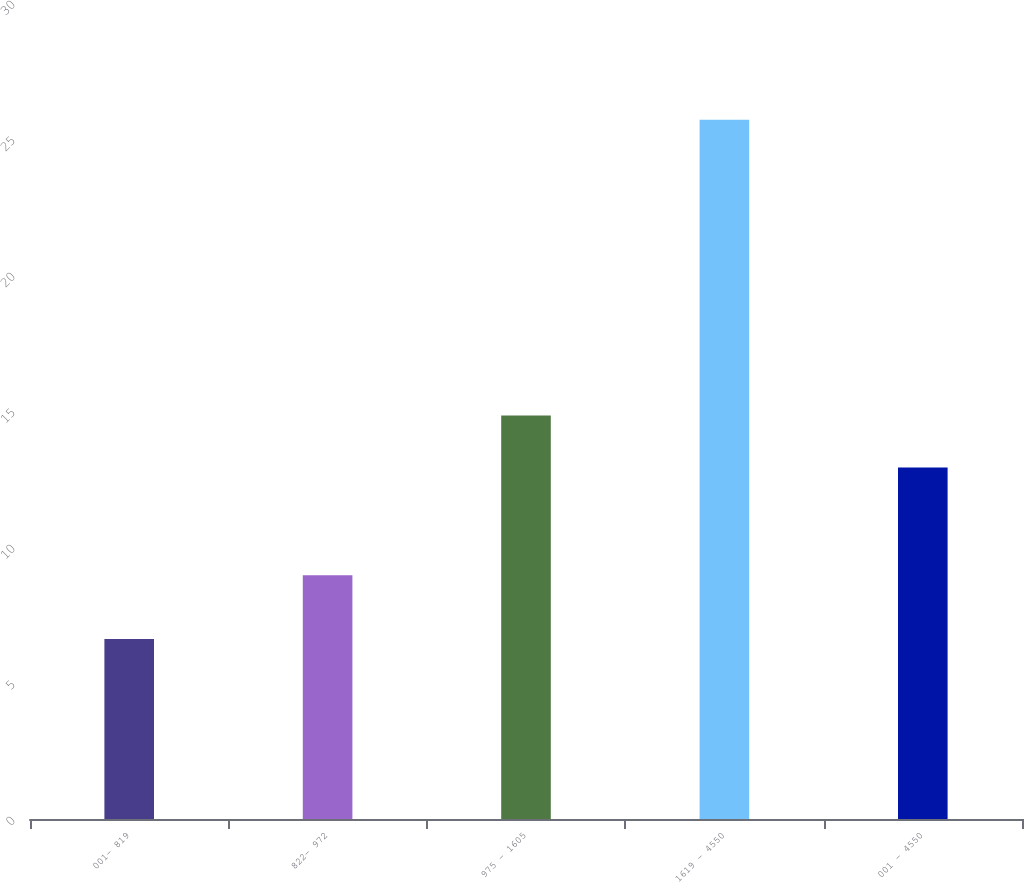Convert chart. <chart><loc_0><loc_0><loc_500><loc_500><bar_chart><fcel>001- 819<fcel>822- 972<fcel>975 - 1605<fcel>1619 - 4550<fcel>001 - 4550<nl><fcel>6.62<fcel>8.96<fcel>14.83<fcel>25.71<fcel>12.92<nl></chart> 